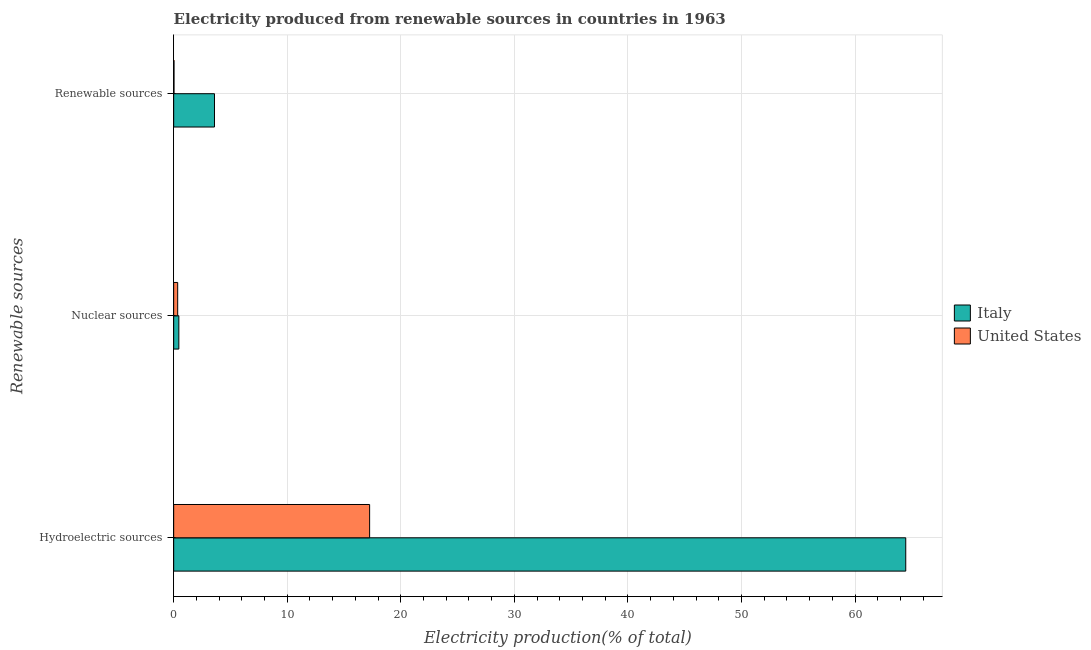How many different coloured bars are there?
Ensure brevity in your answer.  2. Are the number of bars per tick equal to the number of legend labels?
Your answer should be compact. Yes. How many bars are there on the 3rd tick from the top?
Your answer should be compact. 2. What is the label of the 3rd group of bars from the top?
Ensure brevity in your answer.  Hydroelectric sources. What is the percentage of electricity produced by hydroelectric sources in Italy?
Your response must be concise. 64.47. Across all countries, what is the maximum percentage of electricity produced by hydroelectric sources?
Offer a terse response. 64.47. Across all countries, what is the minimum percentage of electricity produced by nuclear sources?
Offer a terse response. 0.35. What is the total percentage of electricity produced by renewable sources in the graph?
Your answer should be compact. 3.62. What is the difference between the percentage of electricity produced by hydroelectric sources in Italy and that in United States?
Offer a very short reply. 47.21. What is the difference between the percentage of electricity produced by nuclear sources in Italy and the percentage of electricity produced by hydroelectric sources in United States?
Offer a terse response. -16.8. What is the average percentage of electricity produced by hydroelectric sources per country?
Make the answer very short. 40.86. What is the difference between the percentage of electricity produced by nuclear sources and percentage of electricity produced by renewable sources in Italy?
Make the answer very short. -3.14. What is the ratio of the percentage of electricity produced by renewable sources in Italy to that in United States?
Offer a very short reply. 122.12. Is the percentage of electricity produced by renewable sources in Italy less than that in United States?
Your answer should be very brief. No. Is the difference between the percentage of electricity produced by renewable sources in Italy and United States greater than the difference between the percentage of electricity produced by nuclear sources in Italy and United States?
Your answer should be compact. Yes. What is the difference between the highest and the second highest percentage of electricity produced by renewable sources?
Offer a very short reply. 3.57. What is the difference between the highest and the lowest percentage of electricity produced by nuclear sources?
Ensure brevity in your answer.  0.1. Is the sum of the percentage of electricity produced by hydroelectric sources in United States and Italy greater than the maximum percentage of electricity produced by nuclear sources across all countries?
Ensure brevity in your answer.  Yes. How many bars are there?
Your answer should be compact. 6. What is the difference between two consecutive major ticks on the X-axis?
Ensure brevity in your answer.  10. Are the values on the major ticks of X-axis written in scientific E-notation?
Make the answer very short. No. Does the graph contain any zero values?
Ensure brevity in your answer.  No. Where does the legend appear in the graph?
Provide a short and direct response. Center right. How many legend labels are there?
Provide a short and direct response. 2. What is the title of the graph?
Keep it short and to the point. Electricity produced from renewable sources in countries in 1963. Does "Tunisia" appear as one of the legend labels in the graph?
Offer a very short reply. No. What is the label or title of the X-axis?
Provide a succinct answer. Electricity production(% of total). What is the label or title of the Y-axis?
Make the answer very short. Renewable sources. What is the Electricity production(% of total) of Italy in Hydroelectric sources?
Keep it short and to the point. 64.47. What is the Electricity production(% of total) of United States in Hydroelectric sources?
Give a very brief answer. 17.26. What is the Electricity production(% of total) of Italy in Nuclear sources?
Give a very brief answer. 0.45. What is the Electricity production(% of total) in United States in Nuclear sources?
Ensure brevity in your answer.  0.35. What is the Electricity production(% of total) in Italy in Renewable sources?
Your answer should be very brief. 3.59. What is the Electricity production(% of total) in United States in Renewable sources?
Your response must be concise. 0.03. Across all Renewable sources, what is the maximum Electricity production(% of total) of Italy?
Ensure brevity in your answer.  64.47. Across all Renewable sources, what is the maximum Electricity production(% of total) of United States?
Provide a succinct answer. 17.26. Across all Renewable sources, what is the minimum Electricity production(% of total) in Italy?
Give a very brief answer. 0.45. Across all Renewable sources, what is the minimum Electricity production(% of total) of United States?
Your answer should be compact. 0.03. What is the total Electricity production(% of total) of Italy in the graph?
Your response must be concise. 68.52. What is the total Electricity production(% of total) of United States in the graph?
Keep it short and to the point. 17.64. What is the difference between the Electricity production(% of total) in Italy in Hydroelectric sources and that in Nuclear sources?
Keep it short and to the point. 64.01. What is the difference between the Electricity production(% of total) of United States in Hydroelectric sources and that in Nuclear sources?
Offer a very short reply. 16.9. What is the difference between the Electricity production(% of total) of Italy in Hydroelectric sources and that in Renewable sources?
Your response must be concise. 60.87. What is the difference between the Electricity production(% of total) of United States in Hydroelectric sources and that in Renewable sources?
Provide a succinct answer. 17.23. What is the difference between the Electricity production(% of total) of Italy in Nuclear sources and that in Renewable sources?
Offer a very short reply. -3.14. What is the difference between the Electricity production(% of total) of United States in Nuclear sources and that in Renewable sources?
Ensure brevity in your answer.  0.32. What is the difference between the Electricity production(% of total) of Italy in Hydroelectric sources and the Electricity production(% of total) of United States in Nuclear sources?
Your answer should be compact. 64.11. What is the difference between the Electricity production(% of total) of Italy in Hydroelectric sources and the Electricity production(% of total) of United States in Renewable sources?
Provide a succinct answer. 64.44. What is the difference between the Electricity production(% of total) of Italy in Nuclear sources and the Electricity production(% of total) of United States in Renewable sources?
Make the answer very short. 0.43. What is the average Electricity production(% of total) of Italy per Renewable sources?
Your response must be concise. 22.84. What is the average Electricity production(% of total) in United States per Renewable sources?
Ensure brevity in your answer.  5.88. What is the difference between the Electricity production(% of total) in Italy and Electricity production(% of total) in United States in Hydroelectric sources?
Provide a short and direct response. 47.21. What is the difference between the Electricity production(% of total) in Italy and Electricity production(% of total) in United States in Nuclear sources?
Make the answer very short. 0.1. What is the difference between the Electricity production(% of total) of Italy and Electricity production(% of total) of United States in Renewable sources?
Keep it short and to the point. 3.56. What is the ratio of the Electricity production(% of total) of Italy in Hydroelectric sources to that in Nuclear sources?
Provide a short and direct response. 141.76. What is the ratio of the Electricity production(% of total) of United States in Hydroelectric sources to that in Nuclear sources?
Your response must be concise. 48.78. What is the ratio of the Electricity production(% of total) of Italy in Hydroelectric sources to that in Renewable sources?
Keep it short and to the point. 17.94. What is the ratio of the Electricity production(% of total) in United States in Hydroelectric sources to that in Renewable sources?
Provide a short and direct response. 586.22. What is the ratio of the Electricity production(% of total) in Italy in Nuclear sources to that in Renewable sources?
Your answer should be very brief. 0.13. What is the ratio of the Electricity production(% of total) in United States in Nuclear sources to that in Renewable sources?
Offer a very short reply. 12.02. What is the difference between the highest and the second highest Electricity production(% of total) of Italy?
Provide a succinct answer. 60.87. What is the difference between the highest and the second highest Electricity production(% of total) of United States?
Your answer should be very brief. 16.9. What is the difference between the highest and the lowest Electricity production(% of total) in Italy?
Make the answer very short. 64.01. What is the difference between the highest and the lowest Electricity production(% of total) of United States?
Ensure brevity in your answer.  17.23. 